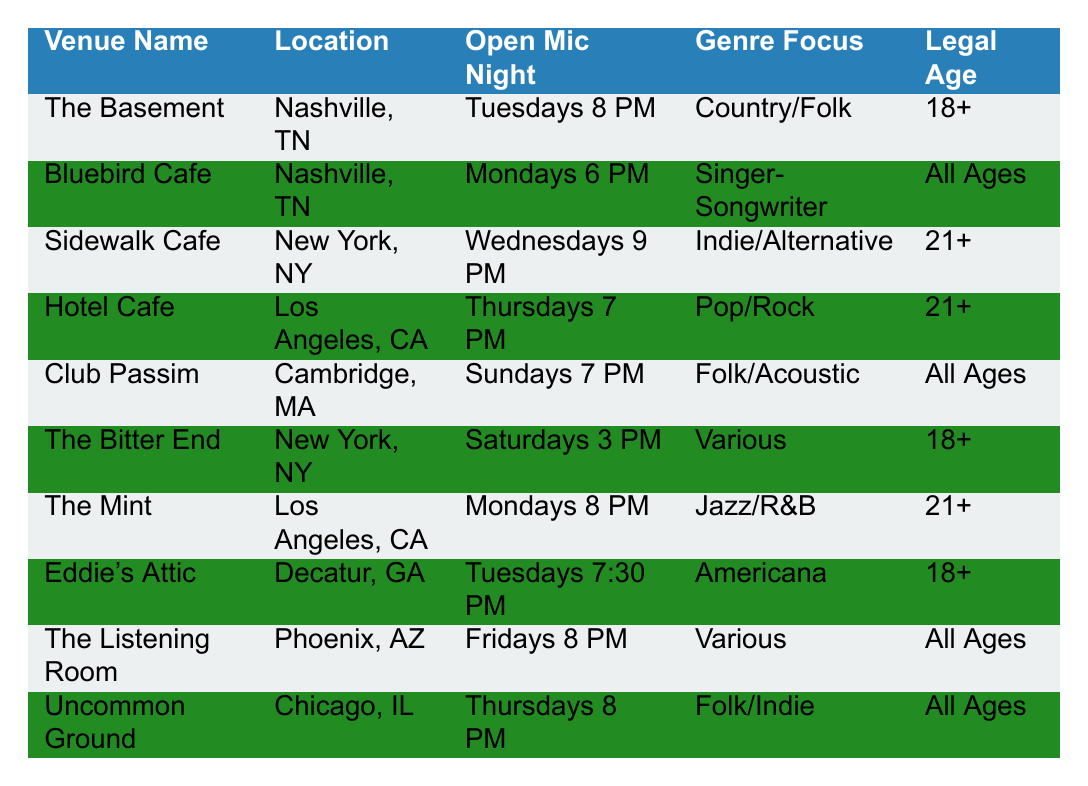What is the Genre Focus for The Basement? The table lists the Venue Name "The Basement," and the corresponding Genre Focus is found in the same row, which is "Country/Folk."
Answer: Country/Folk What are the Open Mic Night timings for Club Passim? The table shows that for the Venue Name "Club Passim," the Open Mic Night is on "Sundays 7 PM."
Answer: Sundays 7 PM Is Eddie's Attic a venue for all ages? The table indicates that for the Venue Name "Eddie's Attic," the Legal Age is "18+." Thus, it is not a venue for all ages.
Answer: No How many venues have an Open Mic Night for 21 and older? We look through the table and find that the venues "Sidewalk Cafe," "Hotel Cafe," and "The Mint" have a Legal Age of "21+," totaling three venues.
Answer: 3 Which venue has an Open Mic Night on Friday? In the table, the Venue Name "The Listening Room" has its Open Mic Night on "Fridays 8 PM."
Answer: The Listening Room Do all venues in Nashville have Open Mic Nights on the same day? The Basement has an Open Mic Night on "Tuesdays 8 PM," and Bluebird Cafe has it on "Mondays 6 PM." Since they are on different days, the answer is no.
Answer: No What is the Legal Age for performers at The Bitter End? According to the table, for the Venue Name "The Bitter End," the Legal Age is "18+."
Answer: 18+ Which city has the most venues listed with Open Mic Nights? By analyzing the table, Nashville has two venues (The Basement and Bluebird Cafe), while other cities have only one venue. Therefore, Nashville has the most venues.
Answer: Nashville 